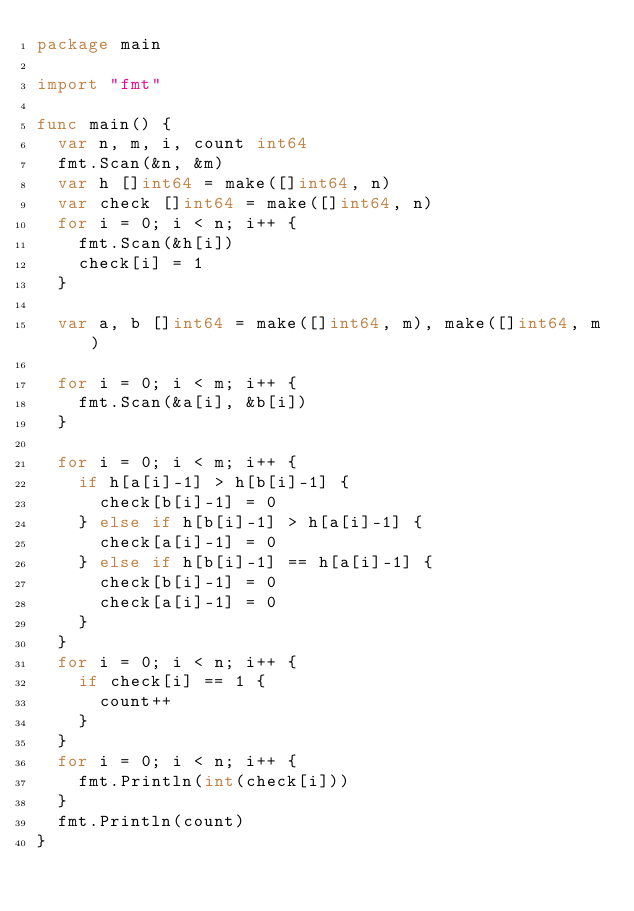Convert code to text. <code><loc_0><loc_0><loc_500><loc_500><_Go_>package main

import "fmt"

func main() {
	var n, m, i, count int64
	fmt.Scan(&n, &m)
	var h []int64 = make([]int64, n)
	var check []int64 = make([]int64, n)
	for i = 0; i < n; i++ {
		fmt.Scan(&h[i])
		check[i] = 1
	}

	var a, b []int64 = make([]int64, m), make([]int64, m)

	for i = 0; i < m; i++ {
		fmt.Scan(&a[i], &b[i])
	}

	for i = 0; i < m; i++ {
		if h[a[i]-1] > h[b[i]-1] {
			check[b[i]-1] = 0
		} else if h[b[i]-1] > h[a[i]-1] {
			check[a[i]-1] = 0
		} else if h[b[i]-1] == h[a[i]-1] {
			check[b[i]-1] = 0
			check[a[i]-1] = 0
		}
	}
	for i = 0; i < n; i++ {
		if check[i] == 1 {
			count++
		}
	}
	for i = 0; i < n; i++ {
		fmt.Println(int(check[i]))
	}
	fmt.Println(count)
}</code> 